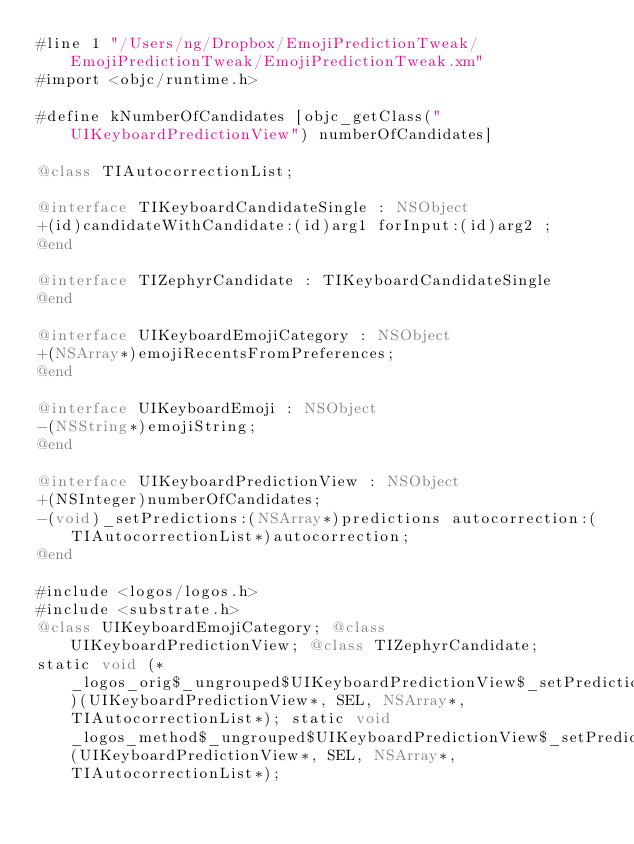<code> <loc_0><loc_0><loc_500><loc_500><_ObjectiveC_>#line 1 "/Users/ng/Dropbox/EmojiPredictionTweak/EmojiPredictionTweak/EmojiPredictionTweak.xm"
#import <objc/runtime.h>

#define kNumberOfCandidates [objc_getClass("UIKeyboardPredictionView") numberOfCandidates]

@class TIAutocorrectionList;

@interface TIKeyboardCandidateSingle : NSObject
+(id)candidateWithCandidate:(id)arg1 forInput:(id)arg2 ;
@end

@interface TIZephyrCandidate : TIKeyboardCandidateSingle
@end

@interface UIKeyboardEmojiCategory : NSObject
+(NSArray*)emojiRecentsFromPreferences;
@end

@interface UIKeyboardEmoji : NSObject
-(NSString*)emojiString;
@end

@interface UIKeyboardPredictionView : NSObject
+(NSInteger)numberOfCandidates;
-(void)_setPredictions:(NSArray*)predictions autocorrection:(TIAutocorrectionList*)autocorrection;
@end

#include <logos/logos.h>
#include <substrate.h>
@class UIKeyboardEmojiCategory; @class UIKeyboardPredictionView; @class TIZephyrCandidate; 
static void (*_logos_orig$_ungrouped$UIKeyboardPredictionView$_setPredictions$autocorrection$)(UIKeyboardPredictionView*, SEL, NSArray*, TIAutocorrectionList*); static void _logos_method$_ungrouped$UIKeyboardPredictionView$_setPredictions$autocorrection$(UIKeyboardPredictionView*, SEL, NSArray*, TIAutocorrectionList*); </code> 